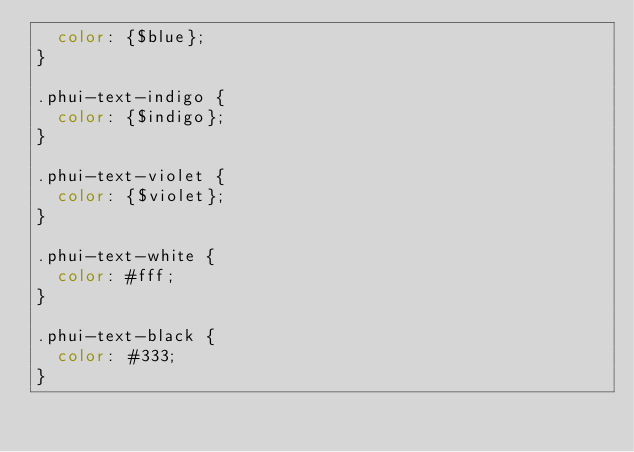<code> <loc_0><loc_0><loc_500><loc_500><_CSS_>  color: {$blue};
}

.phui-text-indigo {
  color: {$indigo};
}

.phui-text-violet {
  color: {$violet};
}

.phui-text-white {
  color: #fff;
}

.phui-text-black {
  color: #333;
}
</code> 